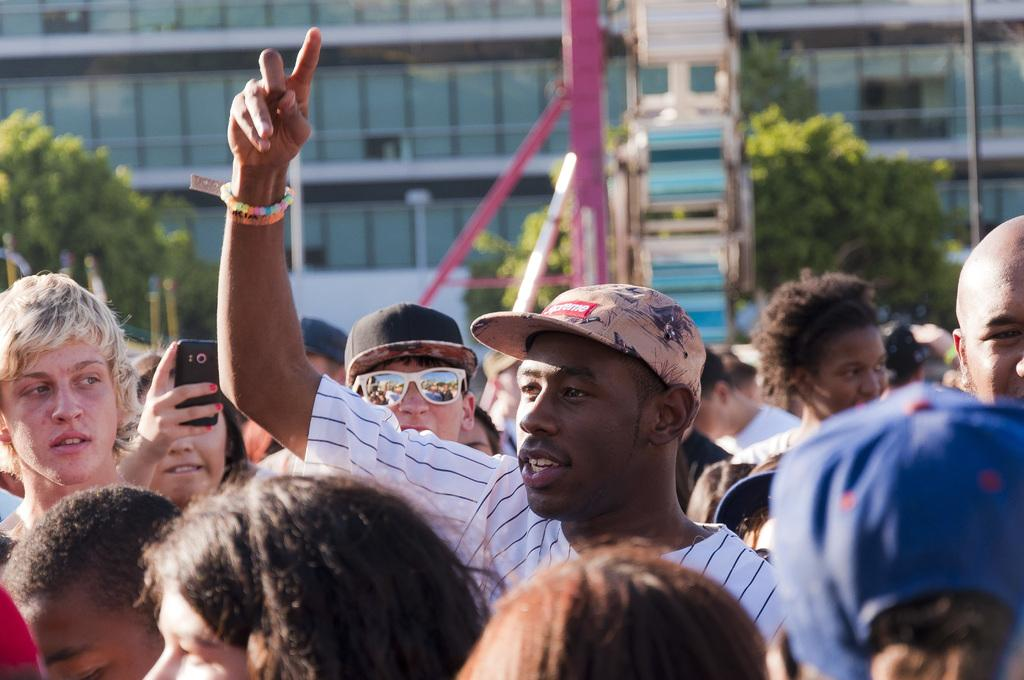How many people are in the image? There is a group of persons in the image, but the exact number cannot be determined from the provided facts. Where are the persons located in the image? The group of persons is on the road in the image. What can be seen in the background of the image? There are trees, a pole, and a building in the background of the image. How many rabbits are hopping around the persons in the image? There are no rabbits present in the image. What type of birds can be seen flying in the background of the image? There is no mention of birds in the image, so it is not possible to determine their presence or type. 